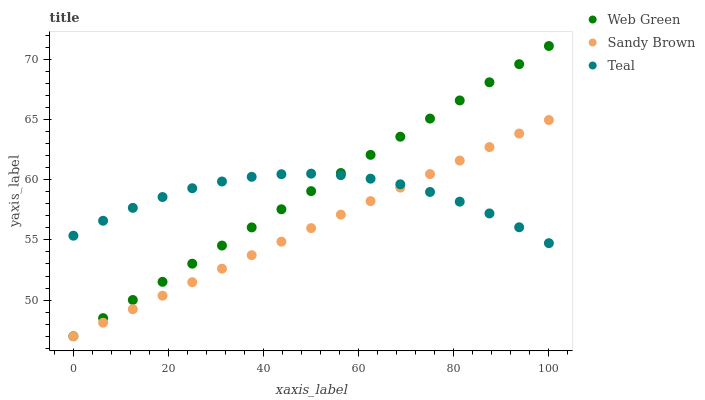Does Sandy Brown have the minimum area under the curve?
Answer yes or no. Yes. Does Web Green have the maximum area under the curve?
Answer yes or no. Yes. Does Teal have the minimum area under the curve?
Answer yes or no. No. Does Teal have the maximum area under the curve?
Answer yes or no. No. Is Sandy Brown the smoothest?
Answer yes or no. Yes. Is Teal the roughest?
Answer yes or no. Yes. Is Teal the smoothest?
Answer yes or no. No. Is Web Green the roughest?
Answer yes or no. No. Does Sandy Brown have the lowest value?
Answer yes or no. Yes. Does Teal have the lowest value?
Answer yes or no. No. Does Web Green have the highest value?
Answer yes or no. Yes. Does Teal have the highest value?
Answer yes or no. No. Does Web Green intersect Teal?
Answer yes or no. Yes. Is Web Green less than Teal?
Answer yes or no. No. Is Web Green greater than Teal?
Answer yes or no. No. 